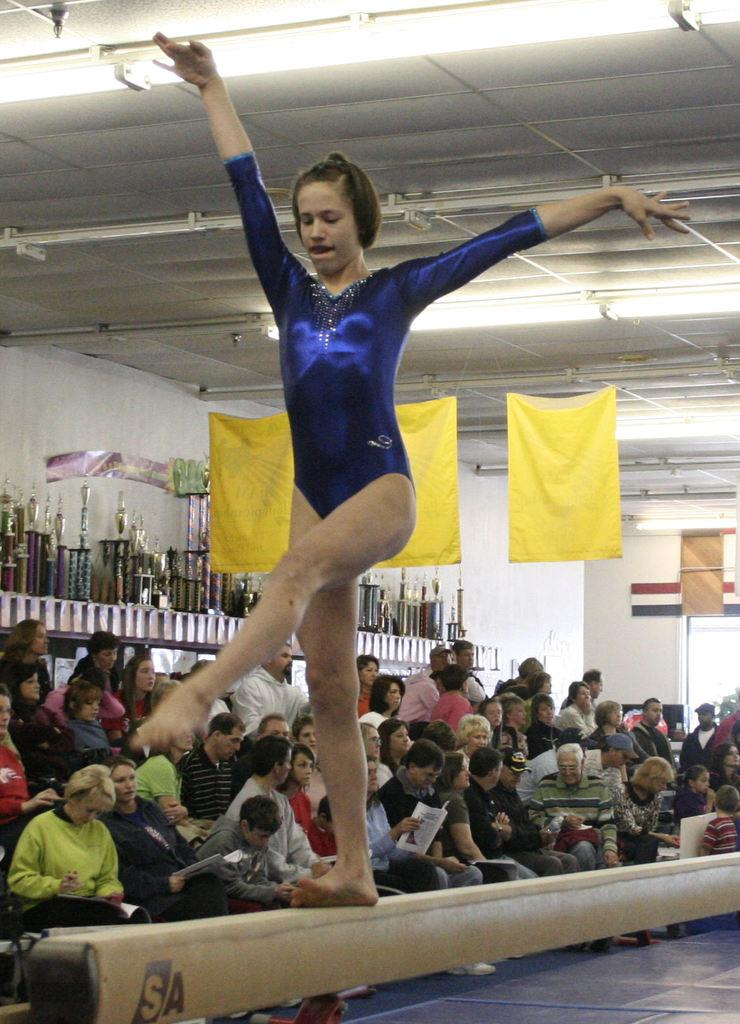What is the main subject in the foreground of the picture? There is a woman in the foreground of the picture. What is the woman doing in the picture? The woman is walking on a pommel horse. What can be seen in the background of the picture? There is a crowd, flags, a ceiling, lights, and prizes in the background of the picture. How many houses can be seen in the background of the picture? There are no houses visible in the background of the picture. What type of needle is being used by the woman in the picture? The woman is not using a needle in the picture; she is walking on a pommel horse. 